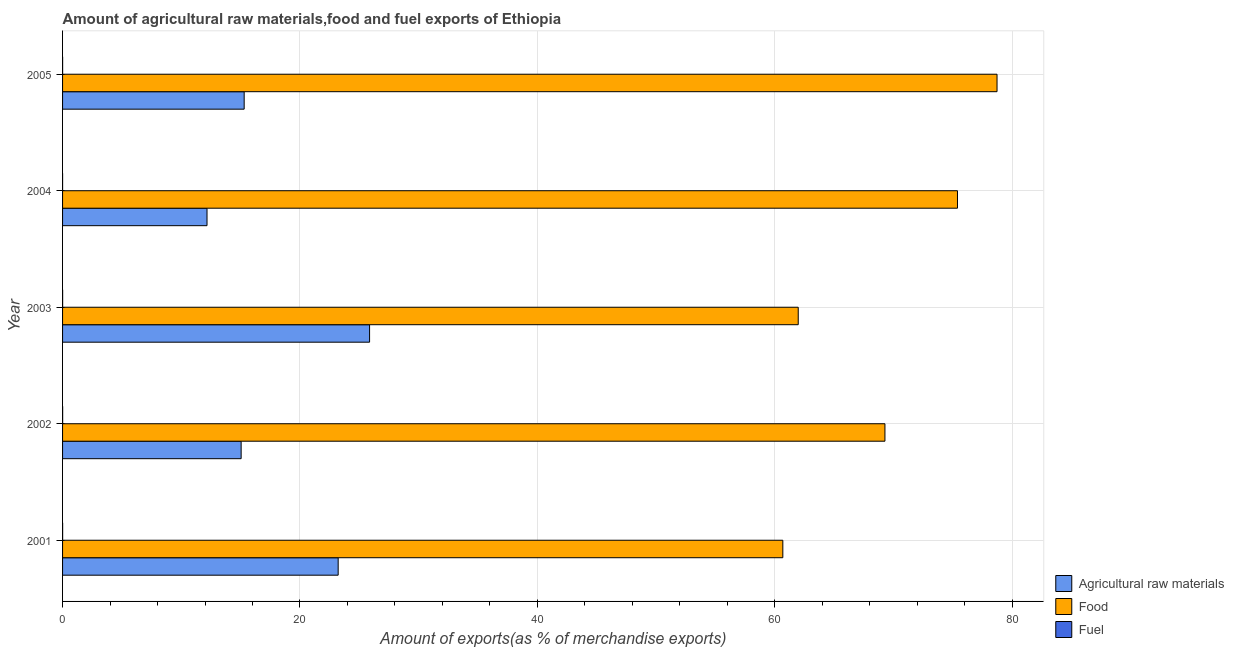Are the number of bars per tick equal to the number of legend labels?
Your answer should be compact. Yes. How many bars are there on the 5th tick from the bottom?
Provide a short and direct response. 3. What is the percentage of fuel exports in 2005?
Your answer should be very brief. 0. Across all years, what is the maximum percentage of raw materials exports?
Keep it short and to the point. 25.87. Across all years, what is the minimum percentage of food exports?
Provide a succinct answer. 60.68. In which year was the percentage of fuel exports minimum?
Provide a short and direct response. 2004. What is the total percentage of raw materials exports in the graph?
Provide a succinct answer. 91.6. What is the difference between the percentage of food exports in 2001 and that in 2003?
Your answer should be very brief. -1.3. What is the difference between the percentage of fuel exports in 2001 and the percentage of food exports in 2005?
Your answer should be compact. -78.72. What is the average percentage of fuel exports per year?
Offer a terse response. 0. In the year 2004, what is the difference between the percentage of fuel exports and percentage of food exports?
Keep it short and to the point. -75.39. What is the ratio of the percentage of raw materials exports in 2004 to that in 2005?
Provide a short and direct response. 0.8. Is the difference between the percentage of fuel exports in 2001 and 2003 greater than the difference between the percentage of raw materials exports in 2001 and 2003?
Your answer should be very brief. Yes. What is the difference between the highest and the second highest percentage of food exports?
Your answer should be compact. 3.33. What is the difference between the highest and the lowest percentage of fuel exports?
Your answer should be very brief. 0.01. In how many years, is the percentage of raw materials exports greater than the average percentage of raw materials exports taken over all years?
Keep it short and to the point. 2. Is the sum of the percentage of fuel exports in 2004 and 2005 greater than the maximum percentage of food exports across all years?
Give a very brief answer. No. What does the 1st bar from the top in 2005 represents?
Provide a short and direct response. Fuel. What does the 3rd bar from the bottom in 2003 represents?
Make the answer very short. Fuel. Does the graph contain any zero values?
Give a very brief answer. No. Does the graph contain grids?
Your answer should be very brief. Yes. Where does the legend appear in the graph?
Your answer should be very brief. Bottom right. How many legend labels are there?
Ensure brevity in your answer.  3. What is the title of the graph?
Ensure brevity in your answer.  Amount of agricultural raw materials,food and fuel exports of Ethiopia. What is the label or title of the X-axis?
Ensure brevity in your answer.  Amount of exports(as % of merchandise exports). What is the label or title of the Y-axis?
Keep it short and to the point. Year. What is the Amount of exports(as % of merchandise exports) in Agricultural raw materials in 2001?
Offer a very short reply. 23.22. What is the Amount of exports(as % of merchandise exports) in Food in 2001?
Your answer should be compact. 60.68. What is the Amount of exports(as % of merchandise exports) of Fuel in 2001?
Your answer should be compact. 0. What is the Amount of exports(as % of merchandise exports) in Agricultural raw materials in 2002?
Offer a very short reply. 15.04. What is the Amount of exports(as % of merchandise exports) in Food in 2002?
Provide a short and direct response. 69.28. What is the Amount of exports(as % of merchandise exports) in Fuel in 2002?
Provide a short and direct response. 0.01. What is the Amount of exports(as % of merchandise exports) of Agricultural raw materials in 2003?
Ensure brevity in your answer.  25.87. What is the Amount of exports(as % of merchandise exports) in Food in 2003?
Provide a succinct answer. 61.98. What is the Amount of exports(as % of merchandise exports) in Fuel in 2003?
Provide a short and direct response. 0.01. What is the Amount of exports(as % of merchandise exports) in Agricultural raw materials in 2004?
Offer a very short reply. 12.17. What is the Amount of exports(as % of merchandise exports) in Food in 2004?
Make the answer very short. 75.39. What is the Amount of exports(as % of merchandise exports) of Fuel in 2004?
Give a very brief answer. 0. What is the Amount of exports(as % of merchandise exports) in Agricultural raw materials in 2005?
Offer a terse response. 15.3. What is the Amount of exports(as % of merchandise exports) in Food in 2005?
Your answer should be very brief. 78.73. What is the Amount of exports(as % of merchandise exports) in Fuel in 2005?
Provide a succinct answer. 0. Across all years, what is the maximum Amount of exports(as % of merchandise exports) of Agricultural raw materials?
Your response must be concise. 25.87. Across all years, what is the maximum Amount of exports(as % of merchandise exports) in Food?
Give a very brief answer. 78.73. Across all years, what is the maximum Amount of exports(as % of merchandise exports) in Fuel?
Give a very brief answer. 0.01. Across all years, what is the minimum Amount of exports(as % of merchandise exports) of Agricultural raw materials?
Your answer should be compact. 12.17. Across all years, what is the minimum Amount of exports(as % of merchandise exports) of Food?
Offer a very short reply. 60.68. Across all years, what is the minimum Amount of exports(as % of merchandise exports) of Fuel?
Ensure brevity in your answer.  0. What is the total Amount of exports(as % of merchandise exports) of Agricultural raw materials in the graph?
Your response must be concise. 91.6. What is the total Amount of exports(as % of merchandise exports) in Food in the graph?
Provide a succinct answer. 346.06. What is the total Amount of exports(as % of merchandise exports) of Fuel in the graph?
Give a very brief answer. 0.02. What is the difference between the Amount of exports(as % of merchandise exports) of Agricultural raw materials in 2001 and that in 2002?
Provide a succinct answer. 8.17. What is the difference between the Amount of exports(as % of merchandise exports) of Food in 2001 and that in 2002?
Your response must be concise. -8.6. What is the difference between the Amount of exports(as % of merchandise exports) of Fuel in 2001 and that in 2002?
Provide a short and direct response. -0. What is the difference between the Amount of exports(as % of merchandise exports) of Agricultural raw materials in 2001 and that in 2003?
Your response must be concise. -2.65. What is the difference between the Amount of exports(as % of merchandise exports) in Food in 2001 and that in 2003?
Make the answer very short. -1.3. What is the difference between the Amount of exports(as % of merchandise exports) of Fuel in 2001 and that in 2003?
Give a very brief answer. -0. What is the difference between the Amount of exports(as % of merchandise exports) of Agricultural raw materials in 2001 and that in 2004?
Give a very brief answer. 11.05. What is the difference between the Amount of exports(as % of merchandise exports) in Food in 2001 and that in 2004?
Provide a succinct answer. -14.71. What is the difference between the Amount of exports(as % of merchandise exports) in Fuel in 2001 and that in 2004?
Keep it short and to the point. 0. What is the difference between the Amount of exports(as % of merchandise exports) in Agricultural raw materials in 2001 and that in 2005?
Give a very brief answer. 7.92. What is the difference between the Amount of exports(as % of merchandise exports) of Food in 2001 and that in 2005?
Offer a terse response. -18.05. What is the difference between the Amount of exports(as % of merchandise exports) in Fuel in 2001 and that in 2005?
Give a very brief answer. 0. What is the difference between the Amount of exports(as % of merchandise exports) of Agricultural raw materials in 2002 and that in 2003?
Your response must be concise. -10.82. What is the difference between the Amount of exports(as % of merchandise exports) in Food in 2002 and that in 2003?
Give a very brief answer. 7.31. What is the difference between the Amount of exports(as % of merchandise exports) of Agricultural raw materials in 2002 and that in 2004?
Make the answer very short. 2.88. What is the difference between the Amount of exports(as % of merchandise exports) of Food in 2002 and that in 2004?
Your answer should be compact. -6.11. What is the difference between the Amount of exports(as % of merchandise exports) in Fuel in 2002 and that in 2004?
Provide a succinct answer. 0.01. What is the difference between the Amount of exports(as % of merchandise exports) in Agricultural raw materials in 2002 and that in 2005?
Give a very brief answer. -0.25. What is the difference between the Amount of exports(as % of merchandise exports) of Food in 2002 and that in 2005?
Your response must be concise. -9.44. What is the difference between the Amount of exports(as % of merchandise exports) of Fuel in 2002 and that in 2005?
Offer a very short reply. 0. What is the difference between the Amount of exports(as % of merchandise exports) of Agricultural raw materials in 2003 and that in 2004?
Offer a terse response. 13.7. What is the difference between the Amount of exports(as % of merchandise exports) of Food in 2003 and that in 2004?
Your answer should be very brief. -13.42. What is the difference between the Amount of exports(as % of merchandise exports) of Fuel in 2003 and that in 2004?
Give a very brief answer. 0. What is the difference between the Amount of exports(as % of merchandise exports) in Agricultural raw materials in 2003 and that in 2005?
Give a very brief answer. 10.57. What is the difference between the Amount of exports(as % of merchandise exports) in Food in 2003 and that in 2005?
Ensure brevity in your answer.  -16.75. What is the difference between the Amount of exports(as % of merchandise exports) of Fuel in 2003 and that in 2005?
Give a very brief answer. 0. What is the difference between the Amount of exports(as % of merchandise exports) of Agricultural raw materials in 2004 and that in 2005?
Your response must be concise. -3.13. What is the difference between the Amount of exports(as % of merchandise exports) of Food in 2004 and that in 2005?
Keep it short and to the point. -3.33. What is the difference between the Amount of exports(as % of merchandise exports) of Fuel in 2004 and that in 2005?
Offer a terse response. -0. What is the difference between the Amount of exports(as % of merchandise exports) in Agricultural raw materials in 2001 and the Amount of exports(as % of merchandise exports) in Food in 2002?
Offer a very short reply. -46.06. What is the difference between the Amount of exports(as % of merchandise exports) in Agricultural raw materials in 2001 and the Amount of exports(as % of merchandise exports) in Fuel in 2002?
Keep it short and to the point. 23.21. What is the difference between the Amount of exports(as % of merchandise exports) of Food in 2001 and the Amount of exports(as % of merchandise exports) of Fuel in 2002?
Make the answer very short. 60.67. What is the difference between the Amount of exports(as % of merchandise exports) in Agricultural raw materials in 2001 and the Amount of exports(as % of merchandise exports) in Food in 2003?
Make the answer very short. -38.76. What is the difference between the Amount of exports(as % of merchandise exports) of Agricultural raw materials in 2001 and the Amount of exports(as % of merchandise exports) of Fuel in 2003?
Your answer should be compact. 23.21. What is the difference between the Amount of exports(as % of merchandise exports) of Food in 2001 and the Amount of exports(as % of merchandise exports) of Fuel in 2003?
Ensure brevity in your answer.  60.68. What is the difference between the Amount of exports(as % of merchandise exports) of Agricultural raw materials in 2001 and the Amount of exports(as % of merchandise exports) of Food in 2004?
Offer a terse response. -52.18. What is the difference between the Amount of exports(as % of merchandise exports) in Agricultural raw materials in 2001 and the Amount of exports(as % of merchandise exports) in Fuel in 2004?
Make the answer very short. 23.22. What is the difference between the Amount of exports(as % of merchandise exports) of Food in 2001 and the Amount of exports(as % of merchandise exports) of Fuel in 2004?
Provide a short and direct response. 60.68. What is the difference between the Amount of exports(as % of merchandise exports) in Agricultural raw materials in 2001 and the Amount of exports(as % of merchandise exports) in Food in 2005?
Provide a short and direct response. -55.51. What is the difference between the Amount of exports(as % of merchandise exports) in Agricultural raw materials in 2001 and the Amount of exports(as % of merchandise exports) in Fuel in 2005?
Your answer should be compact. 23.22. What is the difference between the Amount of exports(as % of merchandise exports) of Food in 2001 and the Amount of exports(as % of merchandise exports) of Fuel in 2005?
Your answer should be very brief. 60.68. What is the difference between the Amount of exports(as % of merchandise exports) in Agricultural raw materials in 2002 and the Amount of exports(as % of merchandise exports) in Food in 2003?
Ensure brevity in your answer.  -46.93. What is the difference between the Amount of exports(as % of merchandise exports) of Agricultural raw materials in 2002 and the Amount of exports(as % of merchandise exports) of Fuel in 2003?
Provide a short and direct response. 15.04. What is the difference between the Amount of exports(as % of merchandise exports) of Food in 2002 and the Amount of exports(as % of merchandise exports) of Fuel in 2003?
Provide a succinct answer. 69.28. What is the difference between the Amount of exports(as % of merchandise exports) of Agricultural raw materials in 2002 and the Amount of exports(as % of merchandise exports) of Food in 2004?
Provide a succinct answer. -60.35. What is the difference between the Amount of exports(as % of merchandise exports) in Agricultural raw materials in 2002 and the Amount of exports(as % of merchandise exports) in Fuel in 2004?
Provide a short and direct response. 15.04. What is the difference between the Amount of exports(as % of merchandise exports) of Food in 2002 and the Amount of exports(as % of merchandise exports) of Fuel in 2004?
Your answer should be compact. 69.28. What is the difference between the Amount of exports(as % of merchandise exports) in Agricultural raw materials in 2002 and the Amount of exports(as % of merchandise exports) in Food in 2005?
Your response must be concise. -63.68. What is the difference between the Amount of exports(as % of merchandise exports) in Agricultural raw materials in 2002 and the Amount of exports(as % of merchandise exports) in Fuel in 2005?
Your answer should be very brief. 15.04. What is the difference between the Amount of exports(as % of merchandise exports) of Food in 2002 and the Amount of exports(as % of merchandise exports) of Fuel in 2005?
Offer a very short reply. 69.28. What is the difference between the Amount of exports(as % of merchandise exports) of Agricultural raw materials in 2003 and the Amount of exports(as % of merchandise exports) of Food in 2004?
Your response must be concise. -49.53. What is the difference between the Amount of exports(as % of merchandise exports) in Agricultural raw materials in 2003 and the Amount of exports(as % of merchandise exports) in Fuel in 2004?
Offer a very short reply. 25.86. What is the difference between the Amount of exports(as % of merchandise exports) in Food in 2003 and the Amount of exports(as % of merchandise exports) in Fuel in 2004?
Keep it short and to the point. 61.98. What is the difference between the Amount of exports(as % of merchandise exports) of Agricultural raw materials in 2003 and the Amount of exports(as % of merchandise exports) of Food in 2005?
Give a very brief answer. -52.86. What is the difference between the Amount of exports(as % of merchandise exports) of Agricultural raw materials in 2003 and the Amount of exports(as % of merchandise exports) of Fuel in 2005?
Ensure brevity in your answer.  25.86. What is the difference between the Amount of exports(as % of merchandise exports) of Food in 2003 and the Amount of exports(as % of merchandise exports) of Fuel in 2005?
Keep it short and to the point. 61.97. What is the difference between the Amount of exports(as % of merchandise exports) in Agricultural raw materials in 2004 and the Amount of exports(as % of merchandise exports) in Food in 2005?
Make the answer very short. -66.56. What is the difference between the Amount of exports(as % of merchandise exports) in Agricultural raw materials in 2004 and the Amount of exports(as % of merchandise exports) in Fuel in 2005?
Keep it short and to the point. 12.17. What is the difference between the Amount of exports(as % of merchandise exports) of Food in 2004 and the Amount of exports(as % of merchandise exports) of Fuel in 2005?
Your answer should be compact. 75.39. What is the average Amount of exports(as % of merchandise exports) in Agricultural raw materials per year?
Provide a succinct answer. 18.32. What is the average Amount of exports(as % of merchandise exports) of Food per year?
Your response must be concise. 69.21. What is the average Amount of exports(as % of merchandise exports) of Fuel per year?
Your answer should be very brief. 0. In the year 2001, what is the difference between the Amount of exports(as % of merchandise exports) of Agricultural raw materials and Amount of exports(as % of merchandise exports) of Food?
Offer a very short reply. -37.46. In the year 2001, what is the difference between the Amount of exports(as % of merchandise exports) of Agricultural raw materials and Amount of exports(as % of merchandise exports) of Fuel?
Give a very brief answer. 23.21. In the year 2001, what is the difference between the Amount of exports(as % of merchandise exports) of Food and Amount of exports(as % of merchandise exports) of Fuel?
Keep it short and to the point. 60.68. In the year 2002, what is the difference between the Amount of exports(as % of merchandise exports) of Agricultural raw materials and Amount of exports(as % of merchandise exports) of Food?
Give a very brief answer. -54.24. In the year 2002, what is the difference between the Amount of exports(as % of merchandise exports) in Agricultural raw materials and Amount of exports(as % of merchandise exports) in Fuel?
Your response must be concise. 15.04. In the year 2002, what is the difference between the Amount of exports(as % of merchandise exports) in Food and Amount of exports(as % of merchandise exports) in Fuel?
Ensure brevity in your answer.  69.28. In the year 2003, what is the difference between the Amount of exports(as % of merchandise exports) of Agricultural raw materials and Amount of exports(as % of merchandise exports) of Food?
Your answer should be very brief. -36.11. In the year 2003, what is the difference between the Amount of exports(as % of merchandise exports) in Agricultural raw materials and Amount of exports(as % of merchandise exports) in Fuel?
Offer a terse response. 25.86. In the year 2003, what is the difference between the Amount of exports(as % of merchandise exports) in Food and Amount of exports(as % of merchandise exports) in Fuel?
Offer a terse response. 61.97. In the year 2004, what is the difference between the Amount of exports(as % of merchandise exports) of Agricultural raw materials and Amount of exports(as % of merchandise exports) of Food?
Offer a terse response. -63.22. In the year 2004, what is the difference between the Amount of exports(as % of merchandise exports) of Agricultural raw materials and Amount of exports(as % of merchandise exports) of Fuel?
Keep it short and to the point. 12.17. In the year 2004, what is the difference between the Amount of exports(as % of merchandise exports) in Food and Amount of exports(as % of merchandise exports) in Fuel?
Your answer should be very brief. 75.39. In the year 2005, what is the difference between the Amount of exports(as % of merchandise exports) in Agricultural raw materials and Amount of exports(as % of merchandise exports) in Food?
Offer a very short reply. -63.43. In the year 2005, what is the difference between the Amount of exports(as % of merchandise exports) of Agricultural raw materials and Amount of exports(as % of merchandise exports) of Fuel?
Your answer should be compact. 15.3. In the year 2005, what is the difference between the Amount of exports(as % of merchandise exports) in Food and Amount of exports(as % of merchandise exports) in Fuel?
Your response must be concise. 78.72. What is the ratio of the Amount of exports(as % of merchandise exports) of Agricultural raw materials in 2001 to that in 2002?
Keep it short and to the point. 1.54. What is the ratio of the Amount of exports(as % of merchandise exports) in Food in 2001 to that in 2002?
Provide a short and direct response. 0.88. What is the ratio of the Amount of exports(as % of merchandise exports) of Fuel in 2001 to that in 2002?
Keep it short and to the point. 0.76. What is the ratio of the Amount of exports(as % of merchandise exports) in Agricultural raw materials in 2001 to that in 2003?
Offer a terse response. 0.9. What is the ratio of the Amount of exports(as % of merchandise exports) of Food in 2001 to that in 2003?
Make the answer very short. 0.98. What is the ratio of the Amount of exports(as % of merchandise exports) of Fuel in 2001 to that in 2003?
Your answer should be very brief. 0.91. What is the ratio of the Amount of exports(as % of merchandise exports) in Agricultural raw materials in 2001 to that in 2004?
Give a very brief answer. 1.91. What is the ratio of the Amount of exports(as % of merchandise exports) of Food in 2001 to that in 2004?
Your answer should be compact. 0.8. What is the ratio of the Amount of exports(as % of merchandise exports) in Fuel in 2001 to that in 2004?
Keep it short and to the point. 5.46. What is the ratio of the Amount of exports(as % of merchandise exports) of Agricultural raw materials in 2001 to that in 2005?
Make the answer very short. 1.52. What is the ratio of the Amount of exports(as % of merchandise exports) of Food in 2001 to that in 2005?
Provide a succinct answer. 0.77. What is the ratio of the Amount of exports(as % of merchandise exports) of Fuel in 2001 to that in 2005?
Provide a succinct answer. 1.23. What is the ratio of the Amount of exports(as % of merchandise exports) in Agricultural raw materials in 2002 to that in 2003?
Make the answer very short. 0.58. What is the ratio of the Amount of exports(as % of merchandise exports) in Food in 2002 to that in 2003?
Provide a short and direct response. 1.12. What is the ratio of the Amount of exports(as % of merchandise exports) of Fuel in 2002 to that in 2003?
Ensure brevity in your answer.  1.2. What is the ratio of the Amount of exports(as % of merchandise exports) of Agricultural raw materials in 2002 to that in 2004?
Offer a terse response. 1.24. What is the ratio of the Amount of exports(as % of merchandise exports) of Food in 2002 to that in 2004?
Give a very brief answer. 0.92. What is the ratio of the Amount of exports(as % of merchandise exports) in Fuel in 2002 to that in 2004?
Provide a succinct answer. 7.21. What is the ratio of the Amount of exports(as % of merchandise exports) of Agricultural raw materials in 2002 to that in 2005?
Your answer should be compact. 0.98. What is the ratio of the Amount of exports(as % of merchandise exports) in Food in 2002 to that in 2005?
Make the answer very short. 0.88. What is the ratio of the Amount of exports(as % of merchandise exports) of Fuel in 2002 to that in 2005?
Offer a terse response. 1.62. What is the ratio of the Amount of exports(as % of merchandise exports) in Agricultural raw materials in 2003 to that in 2004?
Provide a succinct answer. 2.13. What is the ratio of the Amount of exports(as % of merchandise exports) of Food in 2003 to that in 2004?
Keep it short and to the point. 0.82. What is the ratio of the Amount of exports(as % of merchandise exports) in Fuel in 2003 to that in 2004?
Your response must be concise. 6. What is the ratio of the Amount of exports(as % of merchandise exports) in Agricultural raw materials in 2003 to that in 2005?
Your answer should be very brief. 1.69. What is the ratio of the Amount of exports(as % of merchandise exports) in Food in 2003 to that in 2005?
Provide a short and direct response. 0.79. What is the ratio of the Amount of exports(as % of merchandise exports) of Fuel in 2003 to that in 2005?
Offer a terse response. 1.35. What is the ratio of the Amount of exports(as % of merchandise exports) in Agricultural raw materials in 2004 to that in 2005?
Provide a succinct answer. 0.8. What is the ratio of the Amount of exports(as % of merchandise exports) in Food in 2004 to that in 2005?
Provide a succinct answer. 0.96. What is the ratio of the Amount of exports(as % of merchandise exports) of Fuel in 2004 to that in 2005?
Keep it short and to the point. 0.23. What is the difference between the highest and the second highest Amount of exports(as % of merchandise exports) of Agricultural raw materials?
Offer a very short reply. 2.65. What is the difference between the highest and the second highest Amount of exports(as % of merchandise exports) in Food?
Your response must be concise. 3.33. What is the difference between the highest and the second highest Amount of exports(as % of merchandise exports) in Fuel?
Ensure brevity in your answer.  0. What is the difference between the highest and the lowest Amount of exports(as % of merchandise exports) in Agricultural raw materials?
Provide a succinct answer. 13.7. What is the difference between the highest and the lowest Amount of exports(as % of merchandise exports) in Food?
Your answer should be compact. 18.05. What is the difference between the highest and the lowest Amount of exports(as % of merchandise exports) in Fuel?
Your response must be concise. 0.01. 